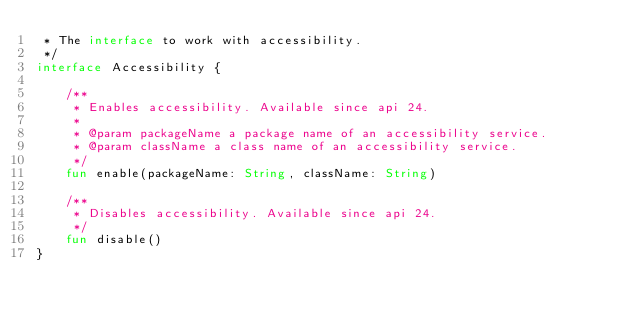<code> <loc_0><loc_0><loc_500><loc_500><_Kotlin_> * The interface to work with accessibility.
 */
interface Accessibility {

    /**
     * Enables accessibility. Available since api 24.
     *
     * @param packageName a package name of an accessibility service.
     * @param className a class name of an accessibility service.
     */
    fun enable(packageName: String, className: String)

    /**
     * Disables accessibility. Available since api 24.
     */
    fun disable()
}
</code> 